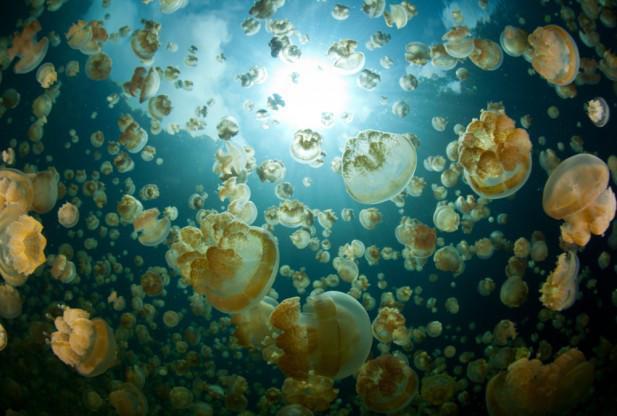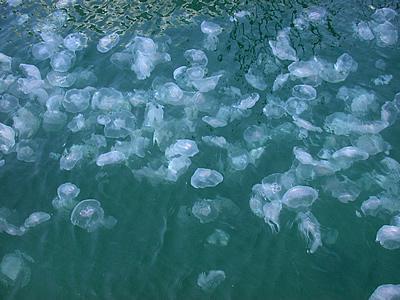The first image is the image on the left, the second image is the image on the right. Assess this claim about the two images: "One photo shows a large group of yellow-tinted jellyfish.". Correct or not? Answer yes or no. Yes. 